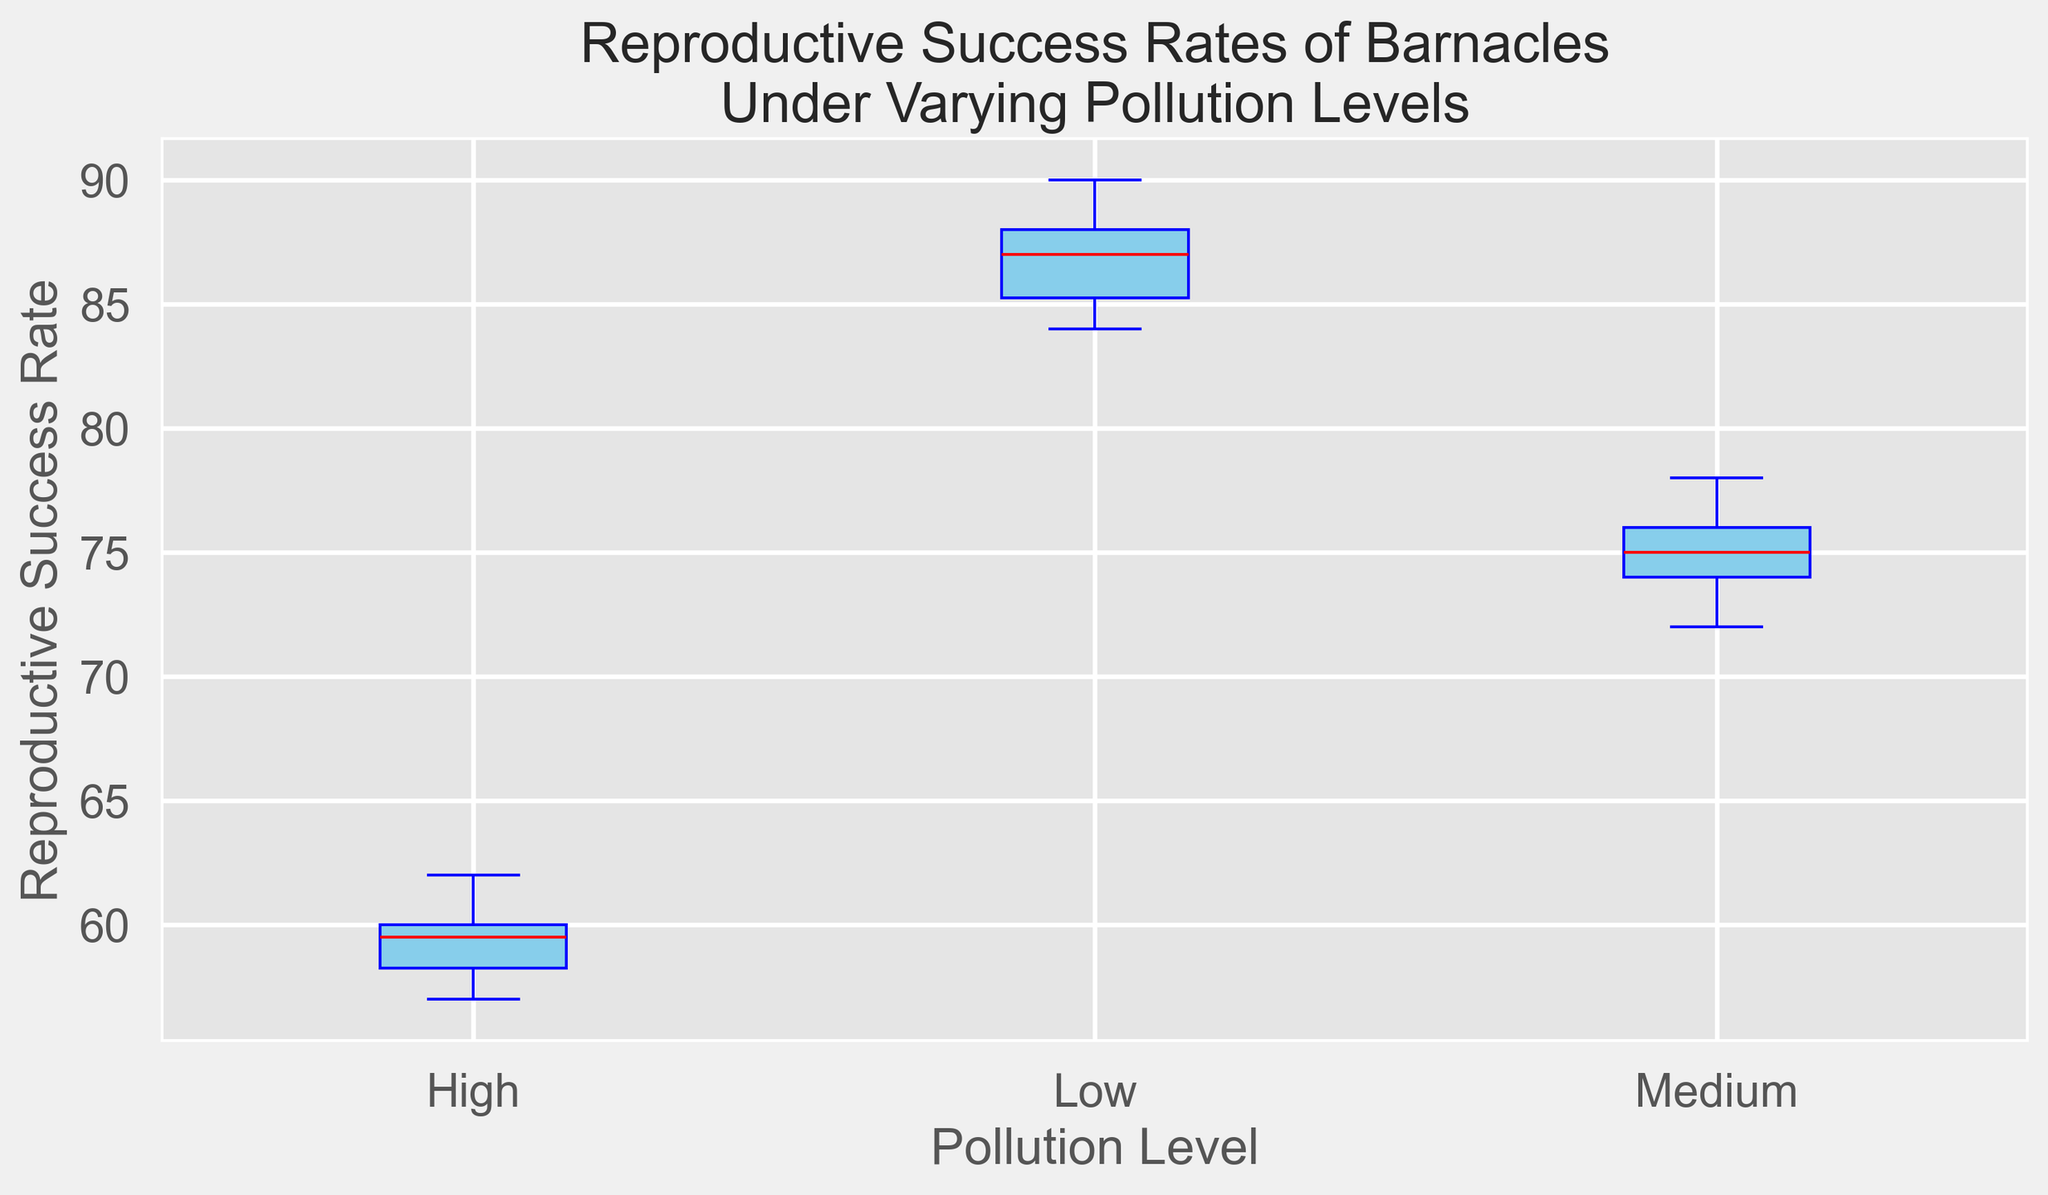What is the median reproductive success rate for barnacles in low pollution levels? The median is the middle value when the data points are ordered. For low pollution levels: 84, 85, 85, 86, 87, 87, 88, 88, 89, 90. The median is the average of the 5th and 6th values, which are both 87.
Answer: 87 Which pollution level shows the lowest overall reproductive success rate for barnacles? Observing the medians marked by red lines, the high pollution level has the lowest median reproductive success rate compared to low and medium pollution levels.
Answer: High How does the spread (interquartile range) of reproductive success rates in medium pollution levels compare to that in low pollution levels? The IQR is the difference between the Q3 (upper quartile) and Q1 (lower quartile). Visually compare the lengths of the boxes: medium level has a larger IQR than the low level, indicating greater variability.
Answer: Medium is larger What is the approximate median reproductive success rate for barnacles under high pollution? The median is indicated by the red line in the box. For the high pollution group, it falls approximately at 59.
Answer: 59 Are there any outliers in the reproductive success rates under any pollution level? Outliers would be marked as individual points outside the whiskers. There are no visible individual points outside of the whiskers for any pollution level.
Answer: No Which pollution level has the most consistent (least variable) reproductive success rate? Consistency can be evaluated by the size of the IQR. The narrower the box, the more consistent the data. Low pollution has the smallest IQR, indicating the most consistent reproductive success rate.
Answer: Low By how much does the median reproductive success rate decrease from low to medium pollution levels? The median for low pollution is 87, and for medium pollution, it is around 75. Subtract the medium from low: 87 - 75 = 12.
Answer: 12 How do the maximum reproductive success rates compare between low and high pollution levels? The maximum is the highest point reached by the top whisker. For low pollution, it’s 90; for high pollution, it is 62.
Answer: Low is higher Is the interquartile range (IQR) of reproductive success rates larger in medium or high pollution levels? Comparing the lengths of their boxes, medium pollution level box is slightly larger than the high pollution level box. Thus, the IQR is larger for medium pollution.
Answer: Medium Does the low pollution level have any success rate that is lower than the highest success rate in high pollution? Compare the lowest value in low pollution (84) with the highest in high pollution (62). Since 84 > 62, none of the data points in low pollution are lower than the highest in high pollution.
Answer: No 